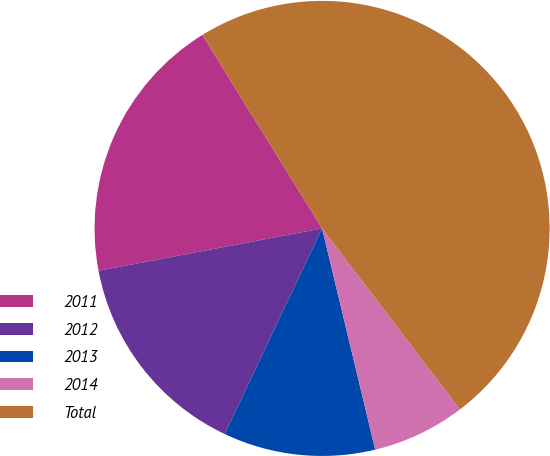Convert chart to OTSL. <chart><loc_0><loc_0><loc_500><loc_500><pie_chart><fcel>2011<fcel>2012<fcel>2013<fcel>2014<fcel>Total<nl><fcel>19.16%<fcel>14.98%<fcel>10.79%<fcel>6.61%<fcel>48.46%<nl></chart> 